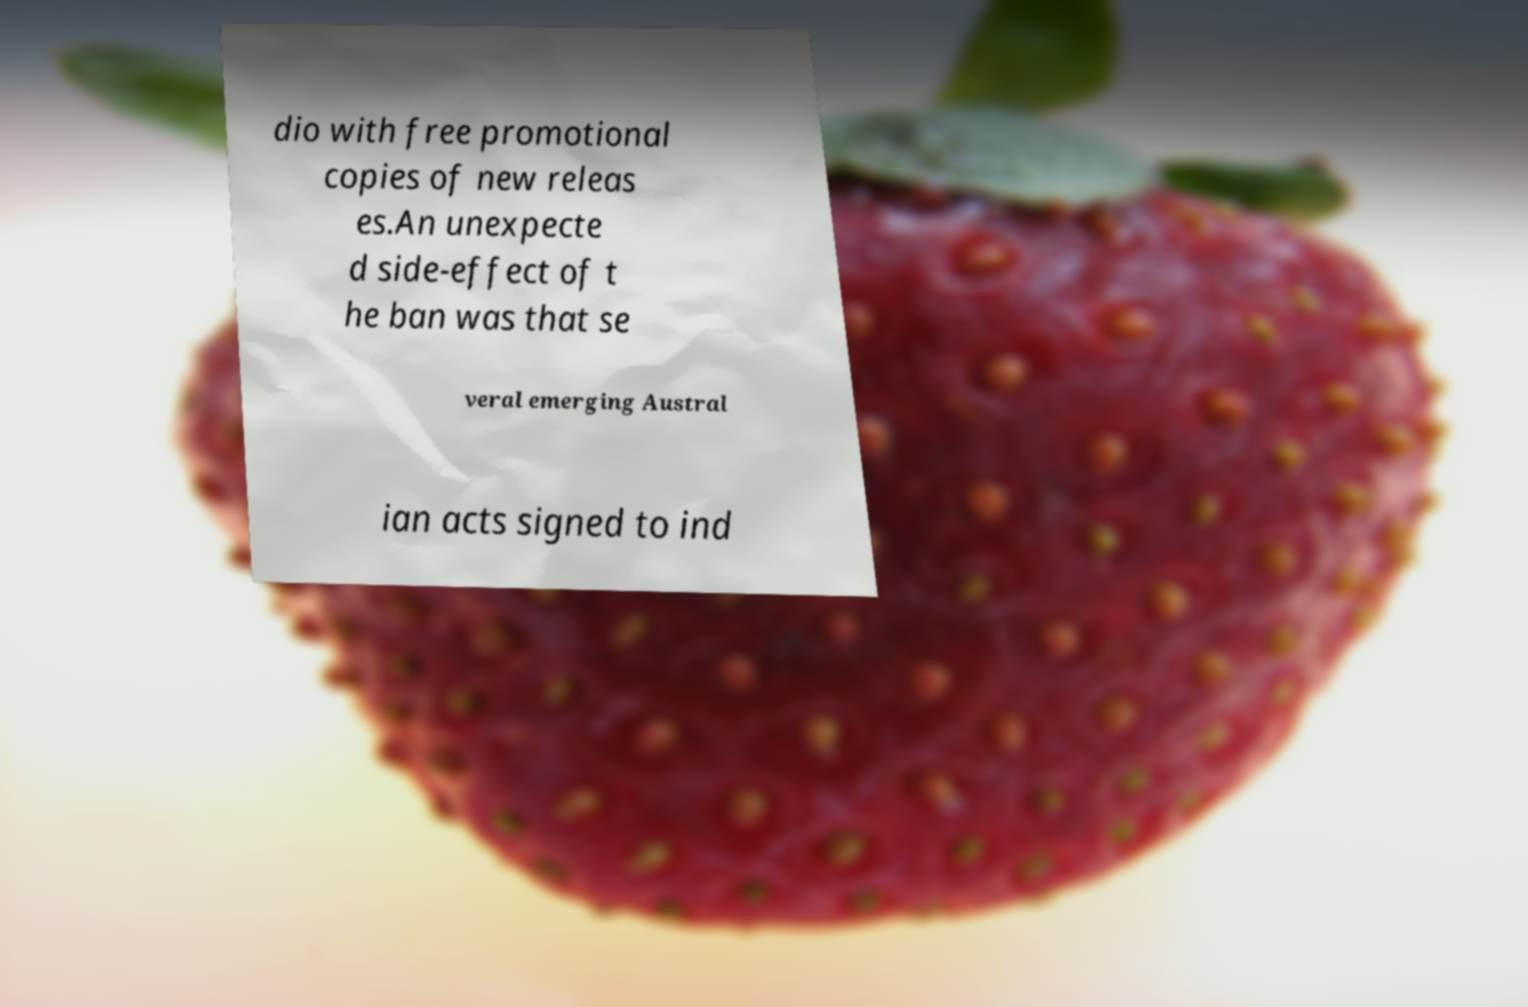I need the written content from this picture converted into text. Can you do that? dio with free promotional copies of new releas es.An unexpecte d side-effect of t he ban was that se veral emerging Austral ian acts signed to ind 